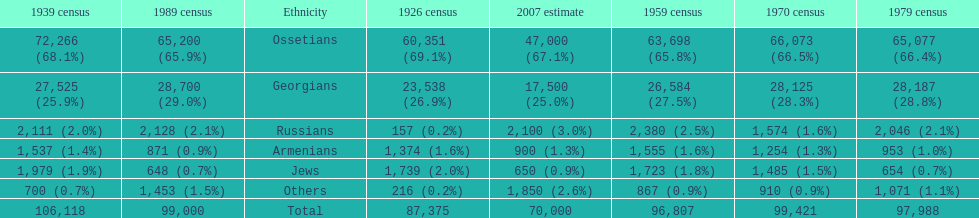Who is previous of the russians based on the list? Georgians. 